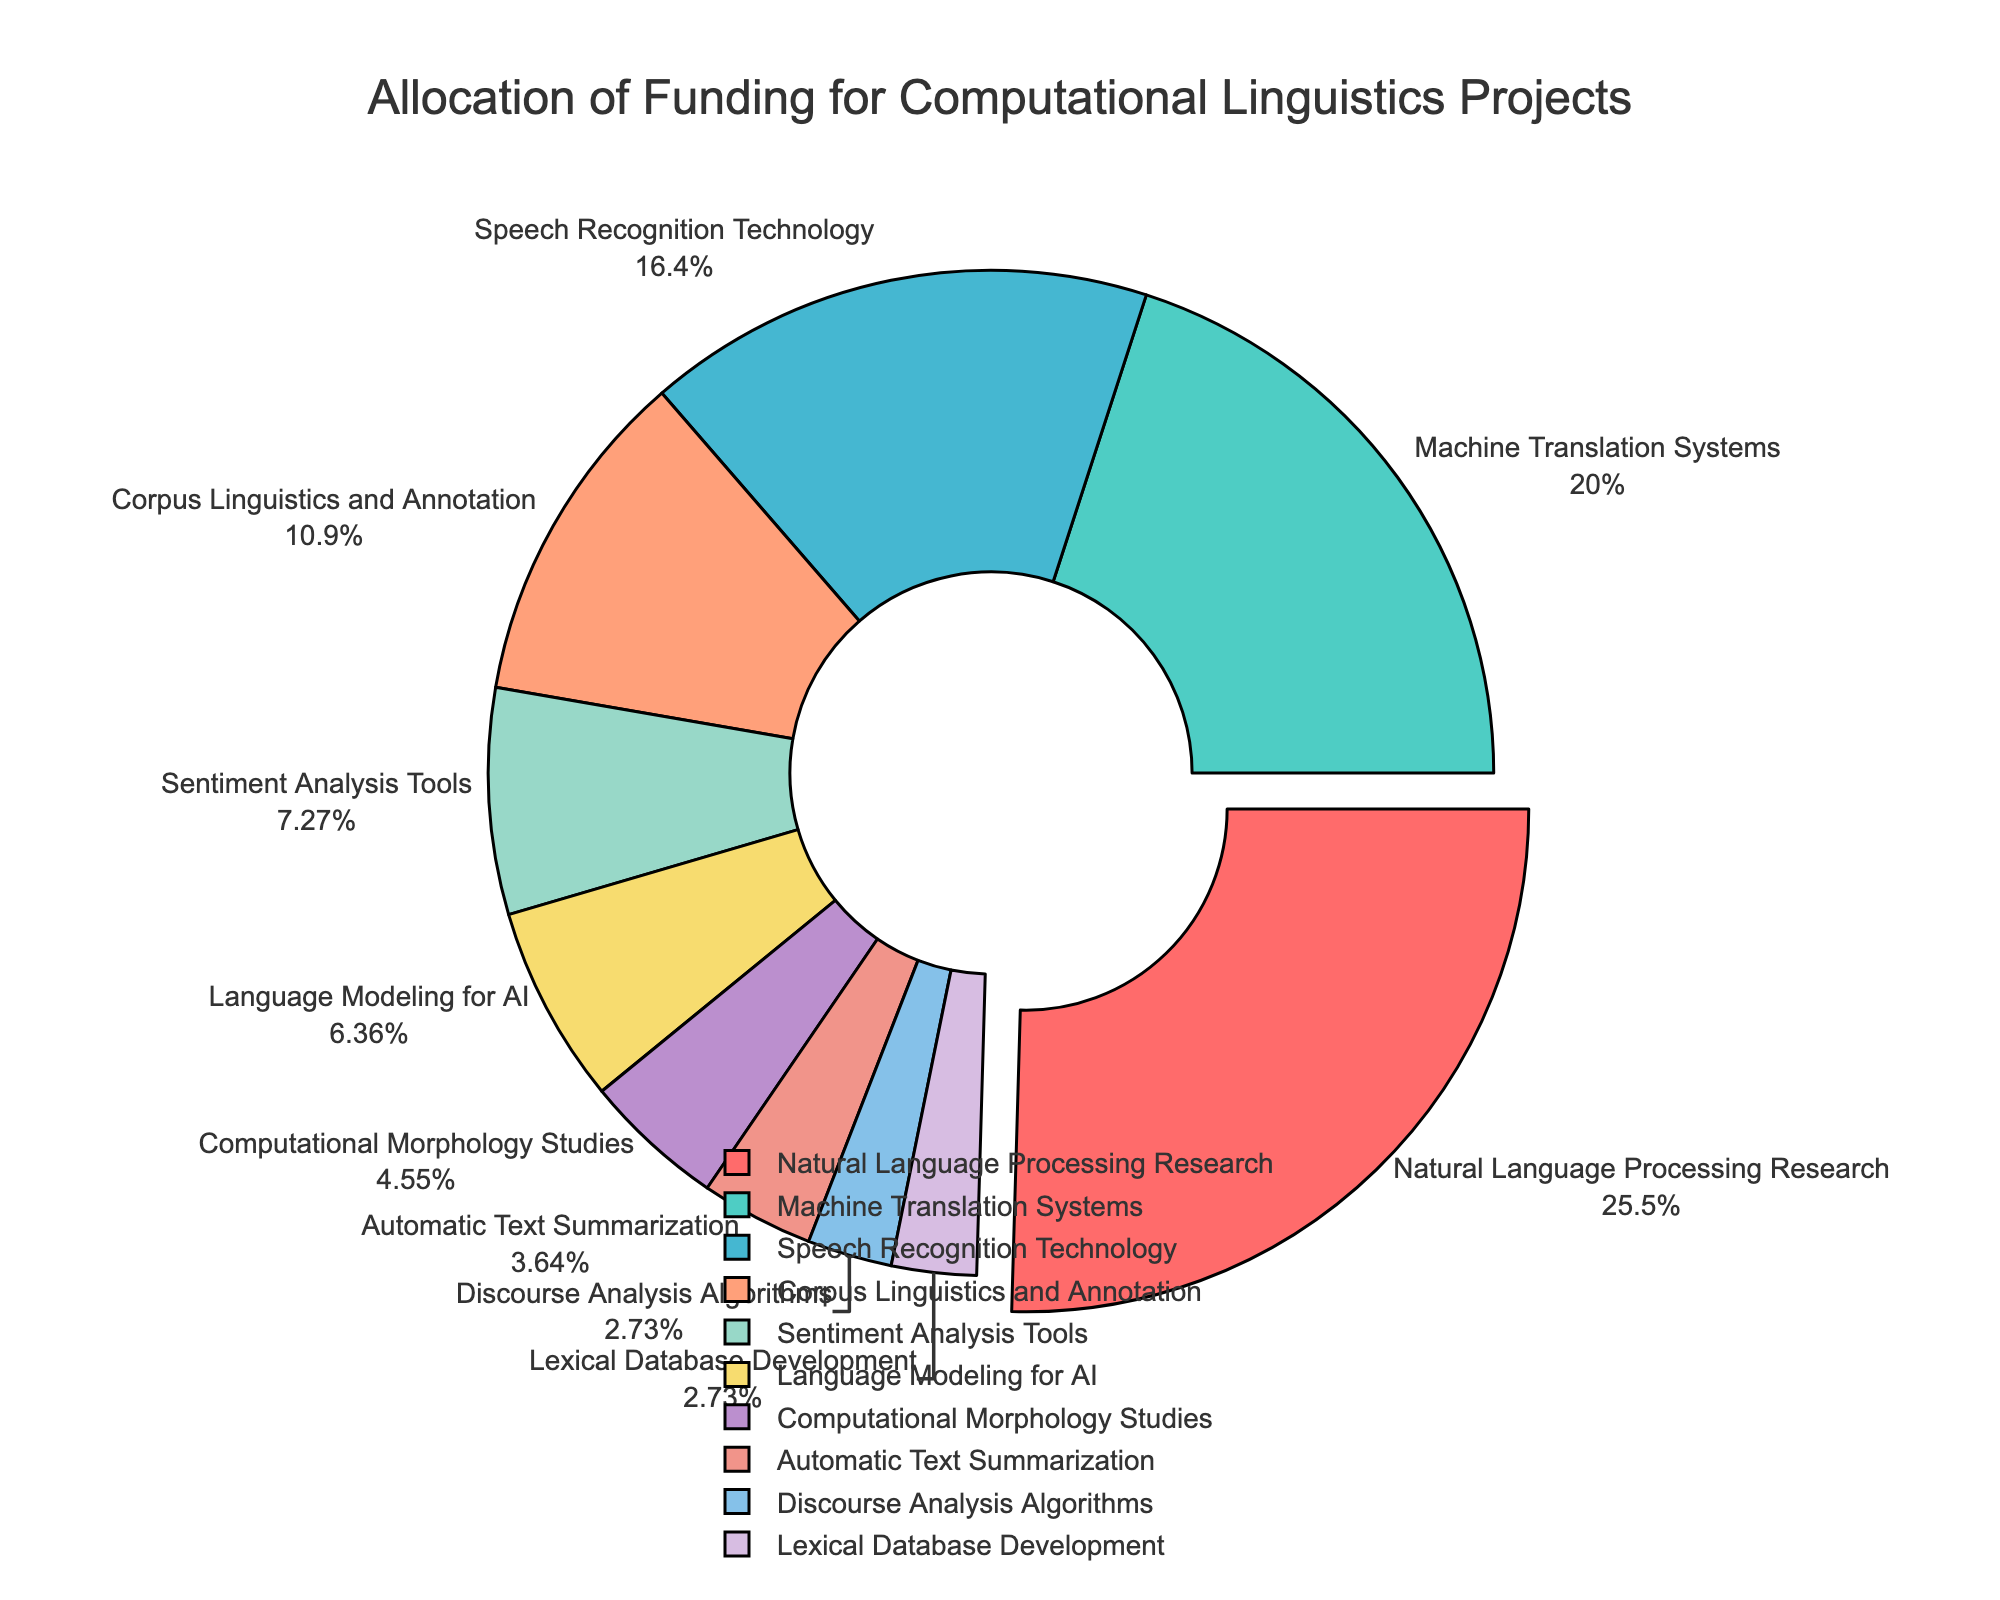Which project received the highest funding allocation? The project with the largest slice in the pie chart, which is also pulled out slightly, represents the one with the highest funding allocation. That slice belongs to "Natural Language Processing Research."
Answer: Natural Language Processing Research What percentage of the total funding is allocated to Machine Translation Systems? The pie chart shows labels with both the project names and their corresponding percentages. The label for Machine Translation Systems shows 22%.
Answer: 22% How much more funding does Speech Recognition Technology receive compared to Corpus Linguistics and Annotation? Speech Recognition Technology's allocation is 18%, and Corpus Linguistics and Annotation's allocation is 12%. The difference between these two is 18% - 12% = 6%.
Answer: 6% Which projects have the smallest funding allocation and what are their combined percentages? The smallest slices in the pie chart represent the projects with 3% funding each, which are "Discourse Analysis Algorithms" and "Lexical Database Development." Adding these gives 3% + 3% = 6%.
Answer: 6% What is the total percentage of funding allocated to Natural Language Processing Research, Machine Translation Systems, and Speech Recognition Technology combined? The funding percentages for these three projects are 28%, 22%, and 18%, respectively. Adding them together: 28% + 22% + 18% = 68%.
Answer: 68% Which project has a yellow-colored slice and how much funding does it receive? The yellow-colored slice in the pie chart corresponds to the "Sentiment Analysis Tools" project, which receives 8% of the funding allocation.
Answer: Sentiment Analysis Tools, 8% Among the projects with a funding allocation below 10%, which one has the largest chunk? Projects with a funding allocation below 10% are "Sentiment Analysis Tools" (8%), "Language Modeling for AI" (7%), "Computational Morphology Studies" (5%), "Automatic Text Summarization" (4%), "Discourse Analysis Algorithms" (3%), and "Lexical Database Development" (3%). Among these, "Sentiment Analysis Tools" has the largest chunk with 8%.
Answer: Sentiment Analysis Tools Compare the combined funding allocation for Corpus Linguistics and Annotation and Language Modeling for AI to the funding allocation for Machine Translation Systems. Which is larger? Corpus Linguistics and Annotation has 12%, and Language Modeling for AI has 7%. Combined, they have 12% + 7% = 19%. Machine Translation Systems have 22%. Therefore, 22% is greater than 19%.
Answer: Machine Translation Systems How does the slice for Automatic Text Summarization compare visually to the slice for Natural Language Processing Research? The slice for Automatic Text Summarization is significantly smaller compared to the much larger and slightly pulled-out slice for Natural Language Processing Research, indicating a much smaller funding allocation.
Answer: Much smaller 